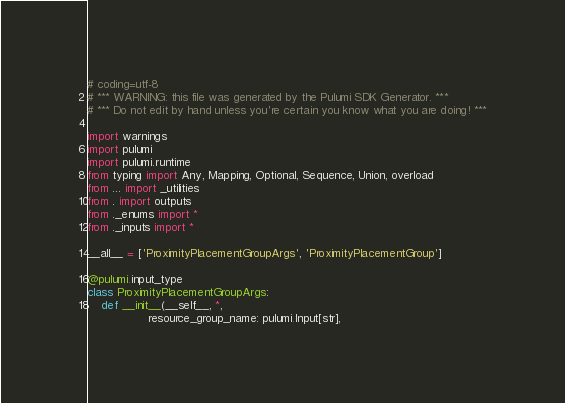Convert code to text. <code><loc_0><loc_0><loc_500><loc_500><_Python_># coding=utf-8
# *** WARNING: this file was generated by the Pulumi SDK Generator. ***
# *** Do not edit by hand unless you're certain you know what you are doing! ***

import warnings
import pulumi
import pulumi.runtime
from typing import Any, Mapping, Optional, Sequence, Union, overload
from ... import _utilities
from . import outputs
from ._enums import *
from ._inputs import *

__all__ = ['ProximityPlacementGroupArgs', 'ProximityPlacementGroup']

@pulumi.input_type
class ProximityPlacementGroupArgs:
    def __init__(__self__, *,
                 resource_group_name: pulumi.Input[str],</code> 